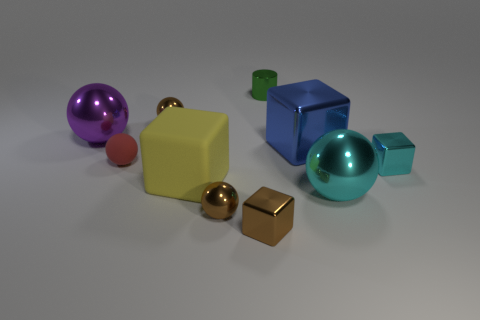Subtract all red cylinders. How many brown spheres are left? 2 Subtract all cyan cubes. How many cubes are left? 3 Subtract all blue cubes. How many cubes are left? 3 Subtract all blocks. How many objects are left? 6 Subtract 2 balls. How many balls are left? 3 Subtract all green balls. Subtract all gray cylinders. How many balls are left? 5 Add 5 small green objects. How many small green objects are left? 6 Add 4 blue matte blocks. How many blue matte blocks exist? 4 Subtract 0 green blocks. How many objects are left? 10 Subtract all green metal things. Subtract all large yellow matte objects. How many objects are left? 8 